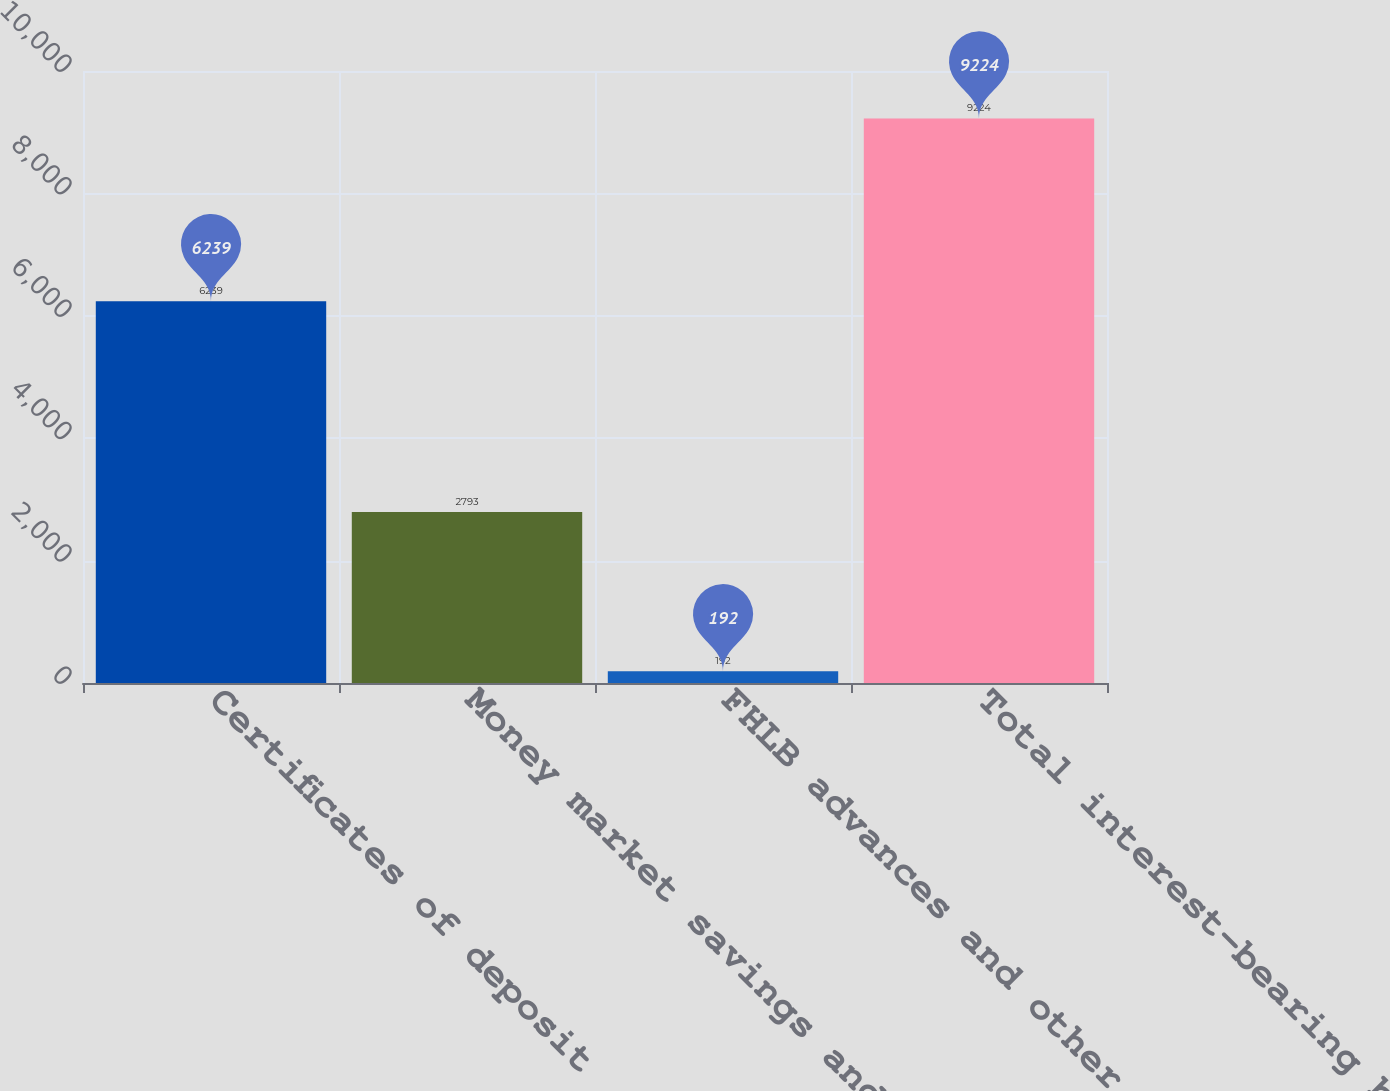<chart> <loc_0><loc_0><loc_500><loc_500><bar_chart><fcel>Certificates of deposit<fcel>Money market savings and NOW<fcel>FHLB advances and other<fcel>Total interest-bearing banking<nl><fcel>6239<fcel>2793<fcel>192<fcel>9224<nl></chart> 